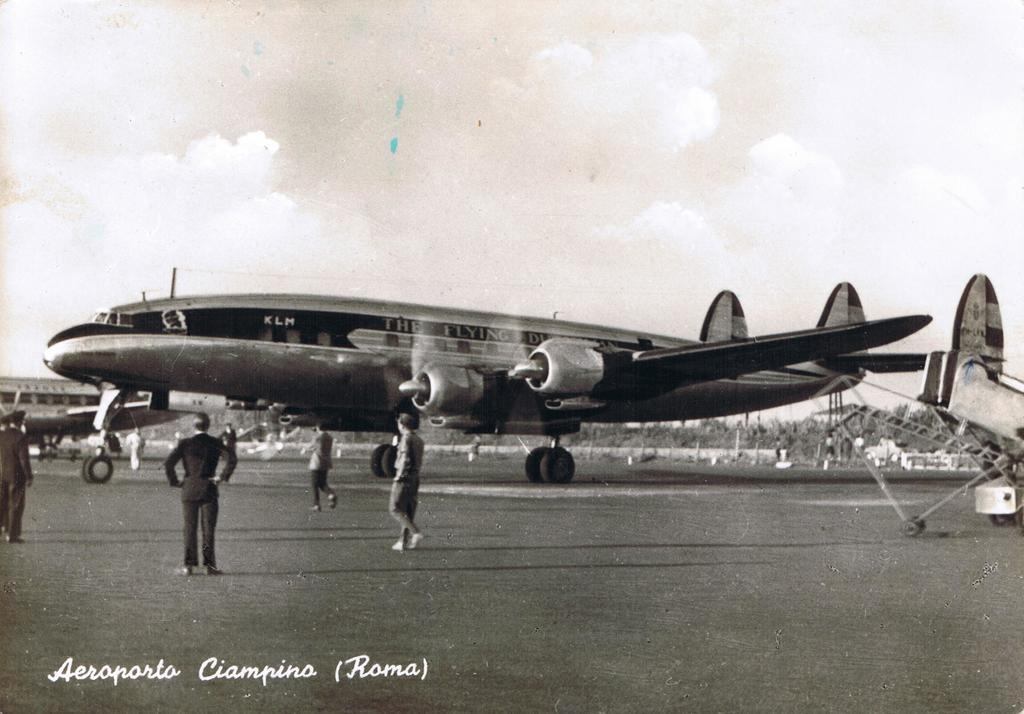<image>
Relay a brief, clear account of the picture shown. The KLM Flying Dutchman is on the ground at the Aeroporto Ciampino. 